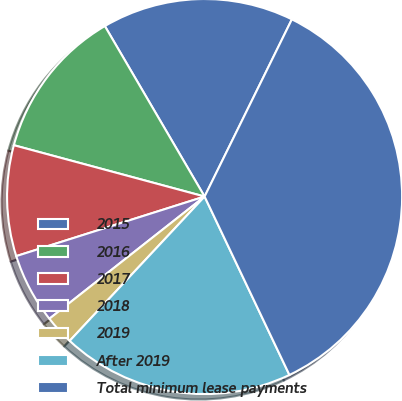Convert chart. <chart><loc_0><loc_0><loc_500><loc_500><pie_chart><fcel>2015<fcel>2016<fcel>2017<fcel>2018<fcel>2019<fcel>After 2019<fcel>Total minimum lease payments<nl><fcel>15.71%<fcel>12.39%<fcel>9.06%<fcel>5.74%<fcel>2.42%<fcel>19.03%<fcel>35.65%<nl></chart> 